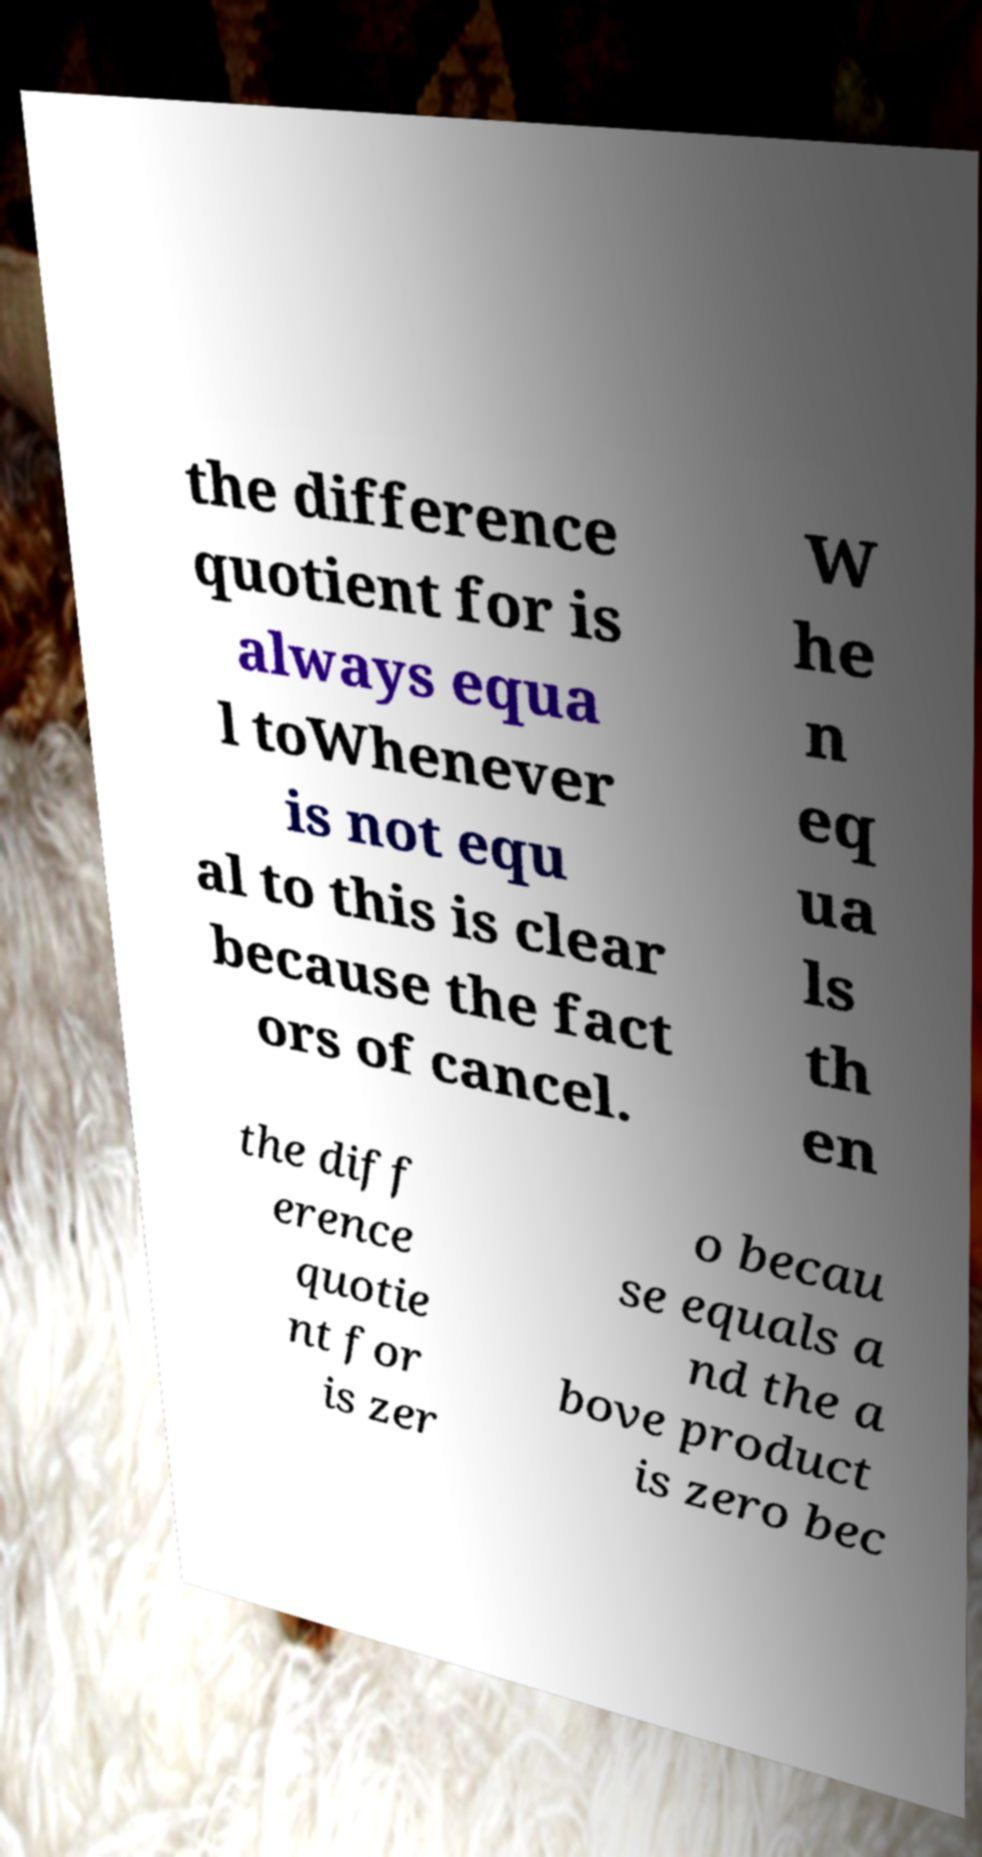Could you extract and type out the text from this image? the difference quotient for is always equa l toWhenever is not equ al to this is clear because the fact ors of cancel. W he n eq ua ls th en the diff erence quotie nt for is zer o becau se equals a nd the a bove product is zero bec 